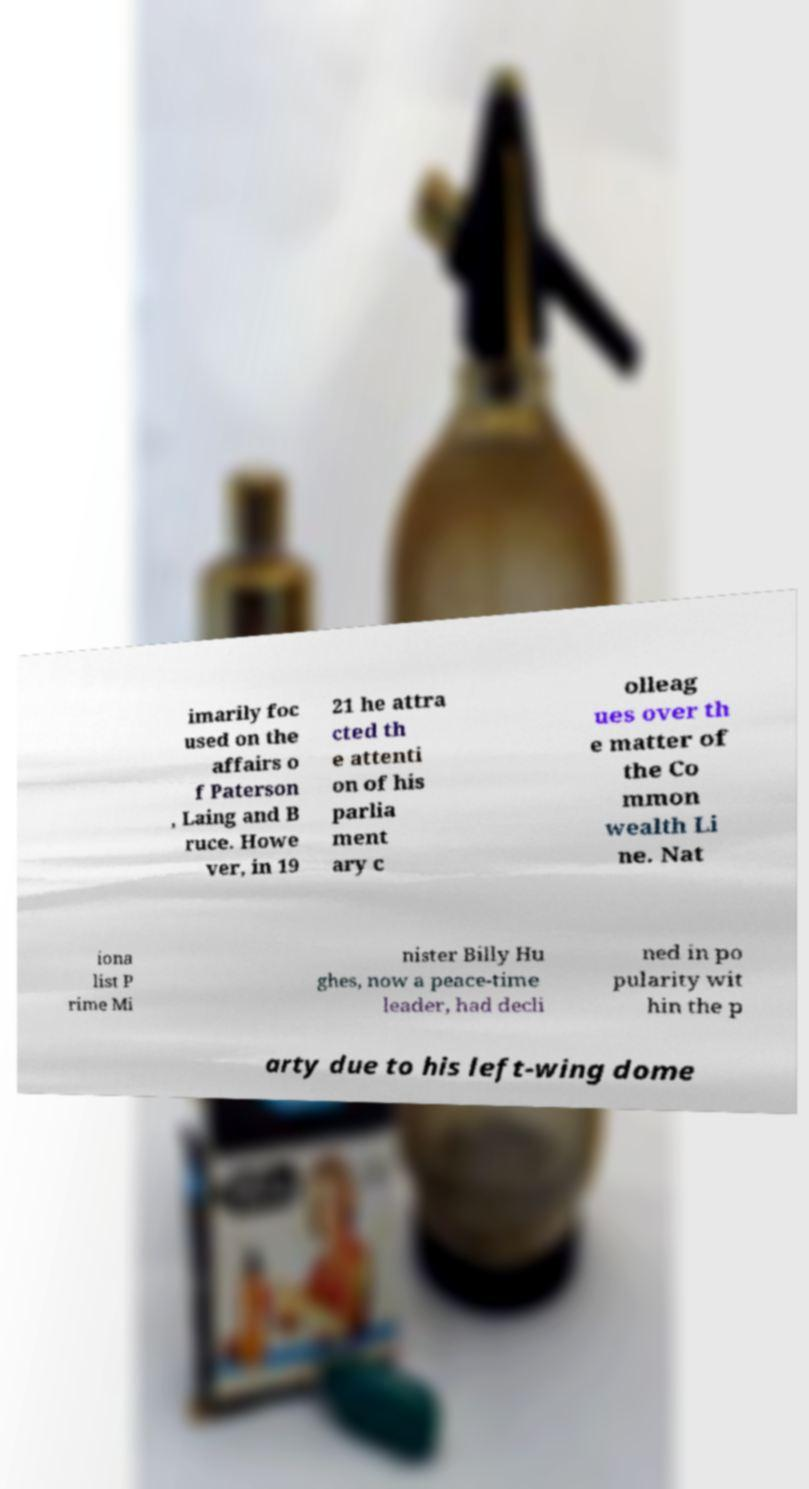Could you assist in decoding the text presented in this image and type it out clearly? imarily foc used on the affairs o f Paterson , Laing and B ruce. Howe ver, in 19 21 he attra cted th e attenti on of his parlia ment ary c olleag ues over th e matter of the Co mmon wealth Li ne. Nat iona list P rime Mi nister Billy Hu ghes, now a peace-time leader, had decli ned in po pularity wit hin the p arty due to his left-wing dome 